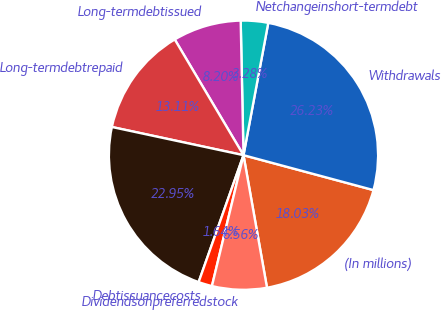Convert chart. <chart><loc_0><loc_0><loc_500><loc_500><pie_chart><fcel>(In millions)<fcel>Withdrawals<fcel>Netchangeinshort-termdebt<fcel>Long-termdebtissued<fcel>Long-termdebtrepaid<fcel>Unnamed: 5<fcel>Debtissuancecosts<fcel>Dividendsonpreferredstock<nl><fcel>18.03%<fcel>26.23%<fcel>3.28%<fcel>8.2%<fcel>13.11%<fcel>22.95%<fcel>1.64%<fcel>6.56%<nl></chart> 